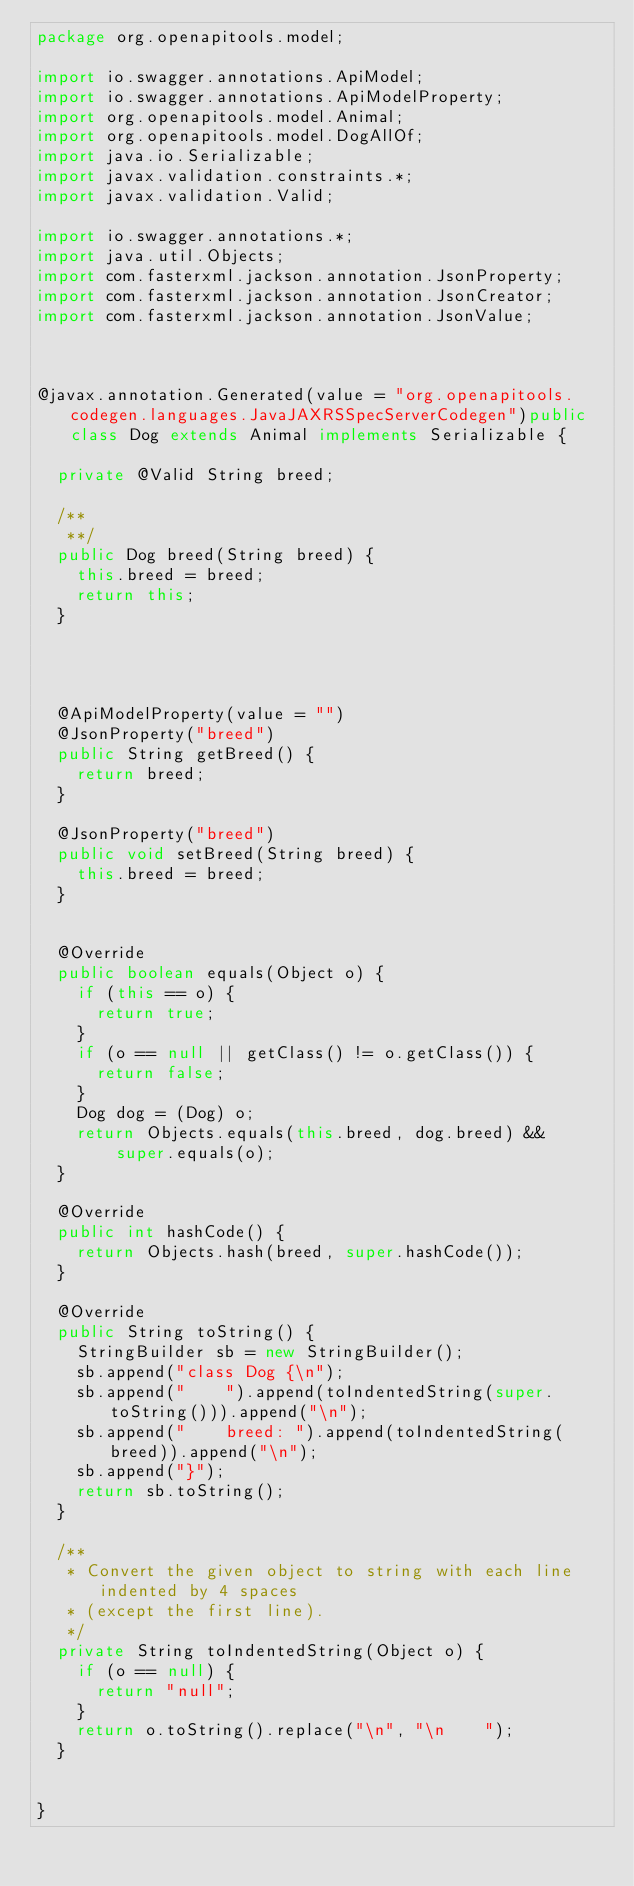<code> <loc_0><loc_0><loc_500><loc_500><_Java_>package org.openapitools.model;

import io.swagger.annotations.ApiModel;
import io.swagger.annotations.ApiModelProperty;
import org.openapitools.model.Animal;
import org.openapitools.model.DogAllOf;
import java.io.Serializable;
import javax.validation.constraints.*;
import javax.validation.Valid;

import io.swagger.annotations.*;
import java.util.Objects;
import com.fasterxml.jackson.annotation.JsonProperty;
import com.fasterxml.jackson.annotation.JsonCreator;
import com.fasterxml.jackson.annotation.JsonValue;



@javax.annotation.Generated(value = "org.openapitools.codegen.languages.JavaJAXRSSpecServerCodegen")public class Dog extends Animal implements Serializable {
  
  private @Valid String breed;

  /**
   **/
  public Dog breed(String breed) {
    this.breed = breed;
    return this;
  }

  

  
  @ApiModelProperty(value = "")
  @JsonProperty("breed")
  public String getBreed() {
    return breed;
  }

  @JsonProperty("breed")
  public void setBreed(String breed) {
    this.breed = breed;
  }


  @Override
  public boolean equals(Object o) {
    if (this == o) {
      return true;
    }
    if (o == null || getClass() != o.getClass()) {
      return false;
    }
    Dog dog = (Dog) o;
    return Objects.equals(this.breed, dog.breed) &&
        super.equals(o);
  }

  @Override
  public int hashCode() {
    return Objects.hash(breed, super.hashCode());
  }

  @Override
  public String toString() {
    StringBuilder sb = new StringBuilder();
    sb.append("class Dog {\n");
    sb.append("    ").append(toIndentedString(super.toString())).append("\n");
    sb.append("    breed: ").append(toIndentedString(breed)).append("\n");
    sb.append("}");
    return sb.toString();
  }

  /**
   * Convert the given object to string with each line indented by 4 spaces
   * (except the first line).
   */
  private String toIndentedString(Object o) {
    if (o == null) {
      return "null";
    }
    return o.toString().replace("\n", "\n    ");
  }


}

</code> 